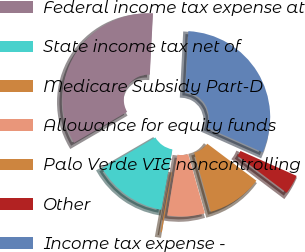Convert chart. <chart><loc_0><loc_0><loc_500><loc_500><pie_chart><fcel>Federal income tax expense at<fcel>State income tax net of<fcel>Medicare Subsidy Part-D<fcel>Allowance for equity funds<fcel>Palo Verde VIE noncontrolling<fcel>Other<fcel>Income tax expense -<nl><fcel>34.21%<fcel>13.73%<fcel>0.25%<fcel>6.99%<fcel>10.36%<fcel>3.62%<fcel>30.84%<nl></chart> 